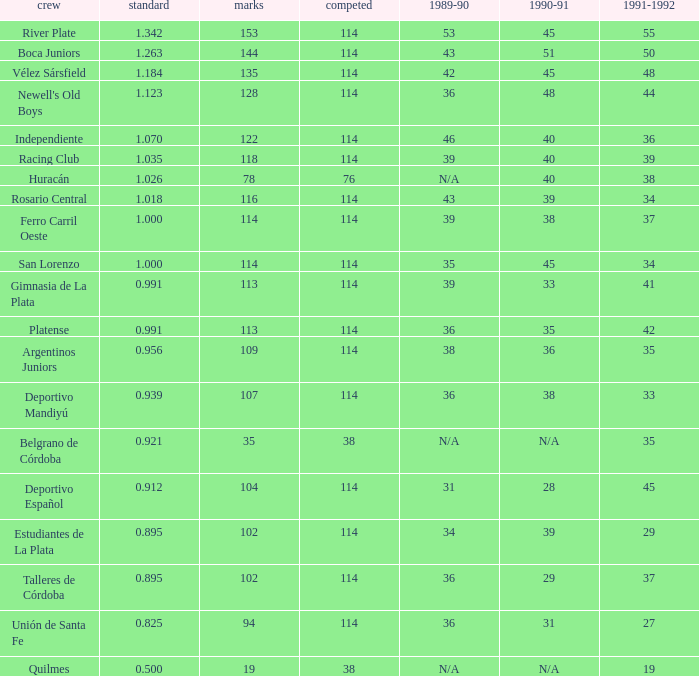How much Played has an Average smaller than 0.9390000000000001, and a 1990-91 of 28? 1.0. 